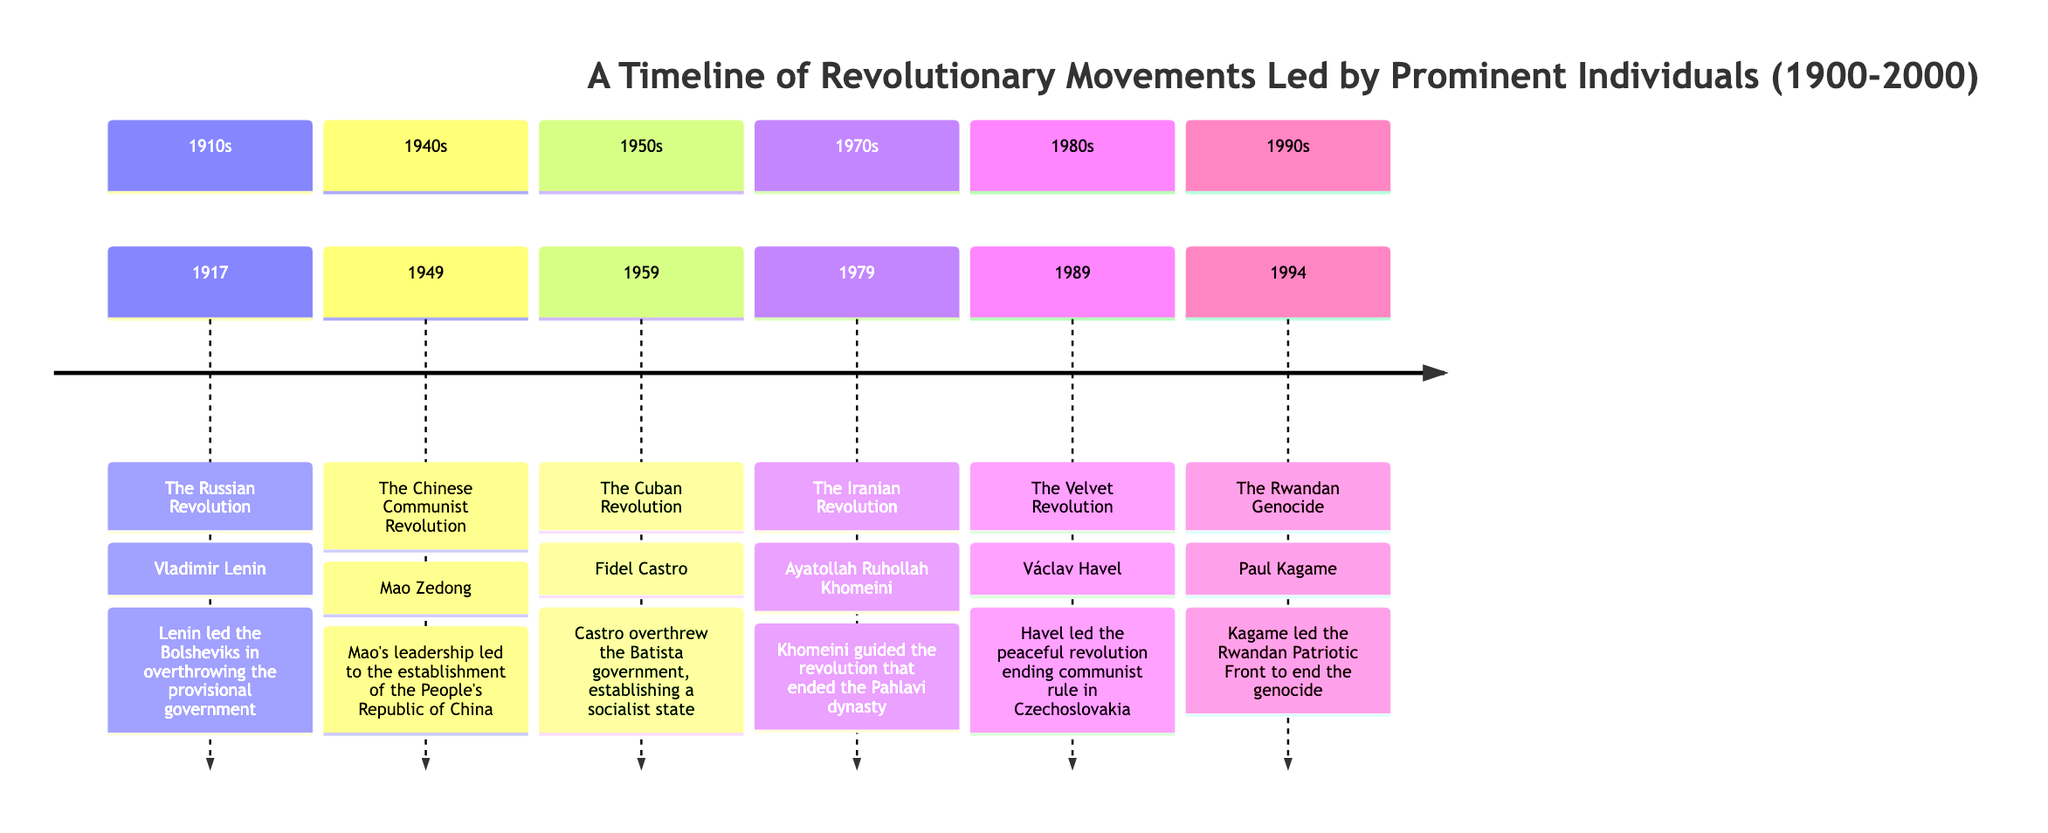What year did the Russian Revolution occur? The timeline indicates the event of the Russian Revolution took place in 1917. The node representing this event clearly states the year right next to it.
Answer: 1917 Who led the Chinese Communist Revolution? The diagram states that Mao Zedong was the leader of the Chinese Communist Revolution. His name is directly listed next to the event in the timeline.
Answer: Mao Zedong What major event occurred in 1989? According to the timeline, the Velvet Revolution is the event that occurred in 1989. This is explicitly mentioned in the section corresponding to that year.
Answer: The Velvet Revolution How many revolutionary movements are listed in the timeline? By counting the individual events mentioned in the timeline, there are six distinct revolutionary movements highlighted. Each event from 1917 to 1994 is accounted for in the entries.
Answer: 6 Which leader was involved in the Iranian Revolution? The timeline identifies Ayatollah Ruhollah Khomeini as the leader associated with the Iranian Revolution. His name is provided in the same entry as the event.
Answer: Ayatollah Ruhollah Khomeini Which event is listed as happening first in the timeline? The Russian Revolution in 1917 is the first event listed in the timeline, making it the earliest event recorded among the movements shown.
Answer: The Russian Revolution What type of government was established after the Cuban Revolution? The timeline describes that the Cuban Revolution led to the establishment of a socialist state. This information is indicated within the event's description.
Answer: A socialist state What was a significant outcome of the Romanian Revolution led by Václav Havel? The timeline notes that the Velvet Revolution led by Václav Havel resulted in the end of 41 years of communist rule in Czechoslovakia, identifying a crucial outcome.
Answer: End of 41 years of communist rule In what year did Paul Kagame play a key role in ending the Rwandan Genocide? According to the timeline, Paul Kagame was instrumental in ending the Rwandan Genocide in 1994, as clearly stated adjacent to the corresponding event.
Answer: 1994 